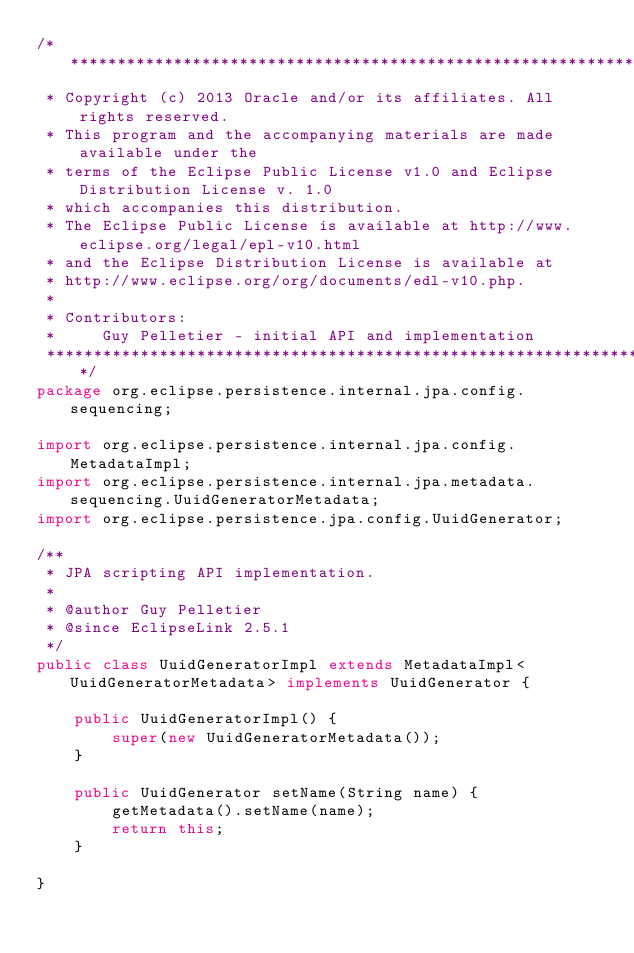<code> <loc_0><loc_0><loc_500><loc_500><_Java_>/*******************************************************************************
 * Copyright (c) 2013 Oracle and/or its affiliates. All rights reserved.
 * This program and the accompanying materials are made available under the 
 * terms of the Eclipse Public License v1.0 and Eclipse Distribution License v. 1.0 
 * which accompanies this distribution. 
 * The Eclipse Public License is available at http://www.eclipse.org/legal/epl-v10.html
 * and the Eclipse Distribution License is available at 
 * http://www.eclipse.org/org/documents/edl-v10.php.
 *
 * Contributors:
 *     Guy Pelletier - initial API and implementation
 ******************************************************************************/
package org.eclipse.persistence.internal.jpa.config.sequencing;

import org.eclipse.persistence.internal.jpa.config.MetadataImpl;
import org.eclipse.persistence.internal.jpa.metadata.sequencing.UuidGeneratorMetadata;
import org.eclipse.persistence.jpa.config.UuidGenerator;

/**
 * JPA scripting API implementation.
 * 
 * @author Guy Pelletier
 * @since EclipseLink 2.5.1
 */
public class UuidGeneratorImpl extends MetadataImpl<UuidGeneratorMetadata> implements UuidGenerator {

    public UuidGeneratorImpl() {
        super(new UuidGeneratorMetadata());
    }

    public UuidGenerator setName(String name) {
        getMetadata().setName(name);
        return this;
    }

}
</code> 